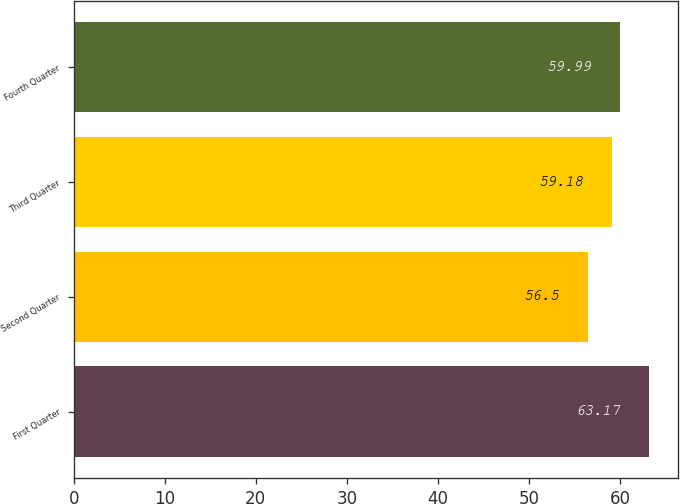<chart> <loc_0><loc_0><loc_500><loc_500><bar_chart><fcel>First Quarter<fcel>Second Quarter<fcel>Third Quarter<fcel>Fourth Quarter<nl><fcel>63.17<fcel>56.5<fcel>59.18<fcel>59.99<nl></chart> 